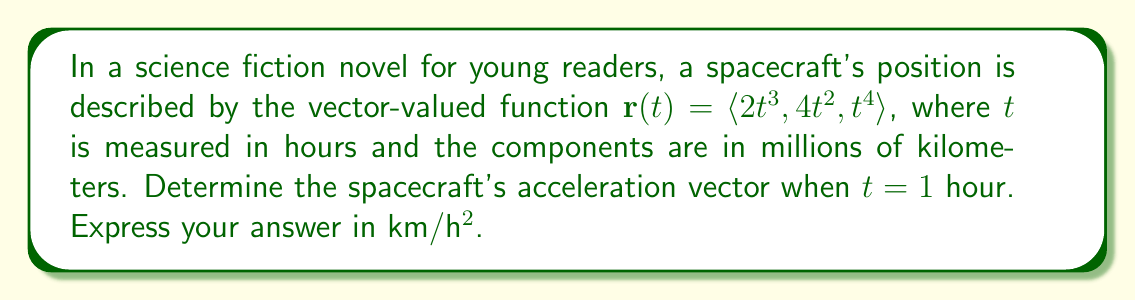Can you answer this question? To find the acceleration of the spacecraft, we need to follow these steps:

1) First, recall that acceleration is the second derivative of position with respect to time.

2) The position vector is given as:
   $$\mathbf{r}(t) = \langle 2t^3, 4t^2, t^4 \rangle$$

3) To find velocity, we take the first derivative:
   $$\mathbf{v}(t) = \mathbf{r}'(t) = \langle 6t^2, 8t, 4t^3 \rangle$$

4) To find acceleration, we take the second derivative:
   $$\mathbf{a}(t) = \mathbf{v}'(t) = \langle 12t, 8, 12t^2 \rangle$$

5) Now, we need to evaluate this at $t = 1$ hour:
   $$\mathbf{a}(1) = \langle 12, 8, 12 \rangle$$

6) However, our answer is currently in millions of km/h². We need to convert it to km/h²:
   $$\mathbf{a}(1) = \langle 12 \times 10^6, 8 \times 10^6, 12 \times 10^6 \rangle \text{ km/h²}$$

Thus, the acceleration vector when $t = 1$ hour is $\langle 12 \times 10^6, 8 \times 10^6, 12 \times 10^6 \rangle$ km/h².
Answer: $\langle 12 \times 10^6, 8 \times 10^6, 12 \times 10^6 \rangle$ km/h² 